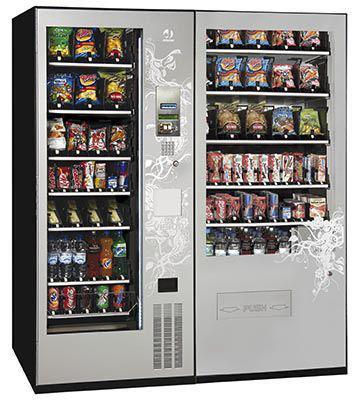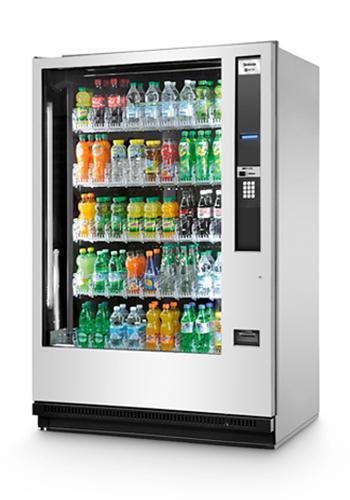The first image is the image on the left, the second image is the image on the right. Given the left and right images, does the statement "In one image, a vending machine unit has a central payment panel with equal sized vending machines on each side with six shelves each." hold true? Answer yes or no. No. 